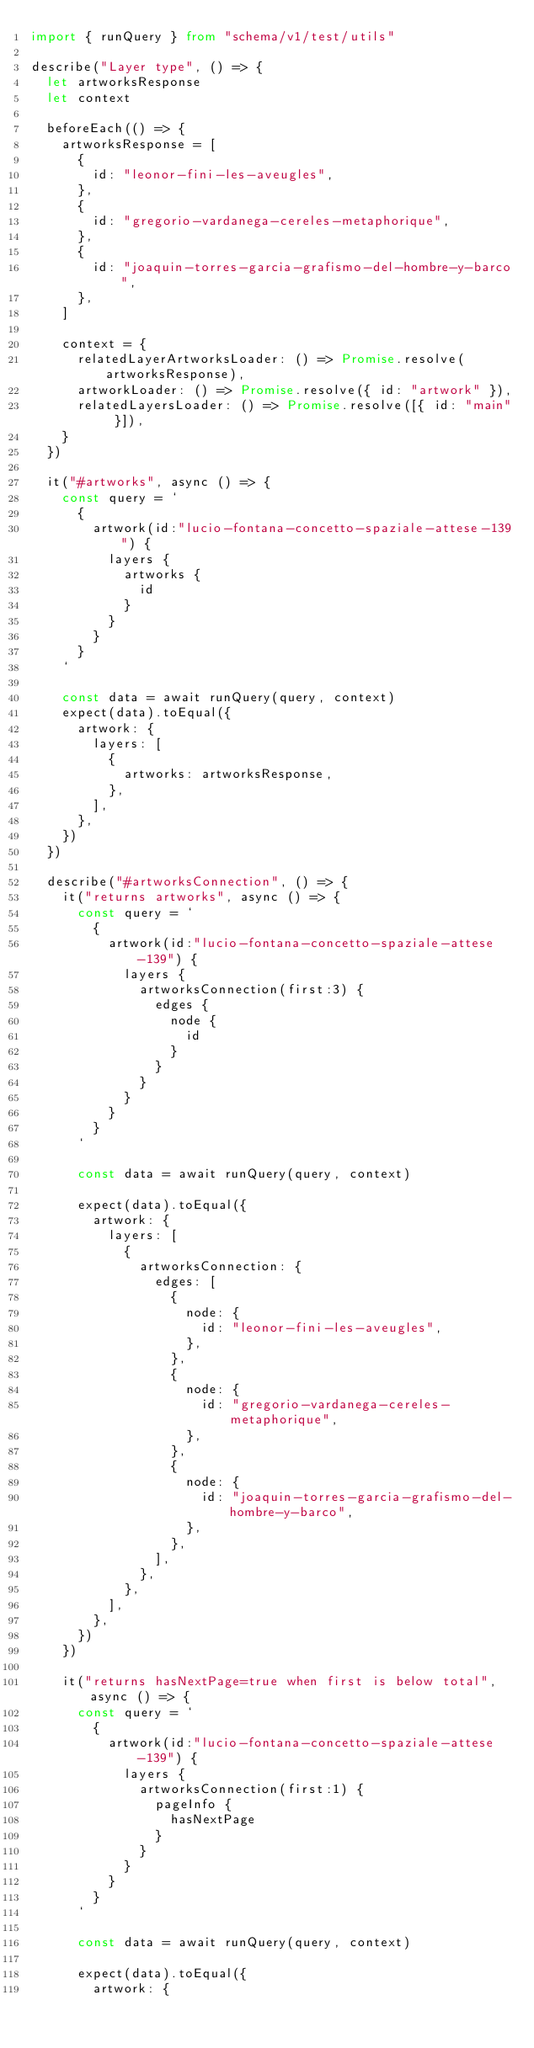Convert code to text. <code><loc_0><loc_0><loc_500><loc_500><_TypeScript_>import { runQuery } from "schema/v1/test/utils"

describe("Layer type", () => {
  let artworksResponse
  let context

  beforeEach(() => {
    artworksResponse = [
      {
        id: "leonor-fini-les-aveugles",
      },
      {
        id: "gregorio-vardanega-cereles-metaphorique",
      },
      {
        id: "joaquin-torres-garcia-grafismo-del-hombre-y-barco",
      },
    ]

    context = {
      relatedLayerArtworksLoader: () => Promise.resolve(artworksResponse),
      artworkLoader: () => Promise.resolve({ id: "artwork" }),
      relatedLayersLoader: () => Promise.resolve([{ id: "main" }]),
    }
  })

  it("#artworks", async () => {
    const query = `
      {
        artwork(id:"lucio-fontana-concetto-spaziale-attese-139") {
          layers {
            artworks {
              id
            }
          }
        }
      }
    `

    const data = await runQuery(query, context)
    expect(data).toEqual({
      artwork: {
        layers: [
          {
            artworks: artworksResponse,
          },
        ],
      },
    })
  })

  describe("#artworksConnection", () => {
    it("returns artworks", async () => {
      const query = `
        {
          artwork(id:"lucio-fontana-concetto-spaziale-attese-139") {
            layers {
              artworksConnection(first:3) {
                edges {
                  node {
                    id
                  }
                }
              }
            }
          }
        }
      `

      const data = await runQuery(query, context)

      expect(data).toEqual({
        artwork: {
          layers: [
            {
              artworksConnection: {
                edges: [
                  {
                    node: {
                      id: "leonor-fini-les-aveugles",
                    },
                  },
                  {
                    node: {
                      id: "gregorio-vardanega-cereles-metaphorique",
                    },
                  },
                  {
                    node: {
                      id: "joaquin-torres-garcia-grafismo-del-hombre-y-barco",
                    },
                  },
                ],
              },
            },
          ],
        },
      })
    })

    it("returns hasNextPage=true when first is below total", async () => {
      const query = `
        {
          artwork(id:"lucio-fontana-concetto-spaziale-attese-139") {
            layers {
              artworksConnection(first:1) {
                pageInfo {
                  hasNextPage
                }
              }
            }
          }
        }
      `

      const data = await runQuery(query, context)

      expect(data).toEqual({
        artwork: {</code> 